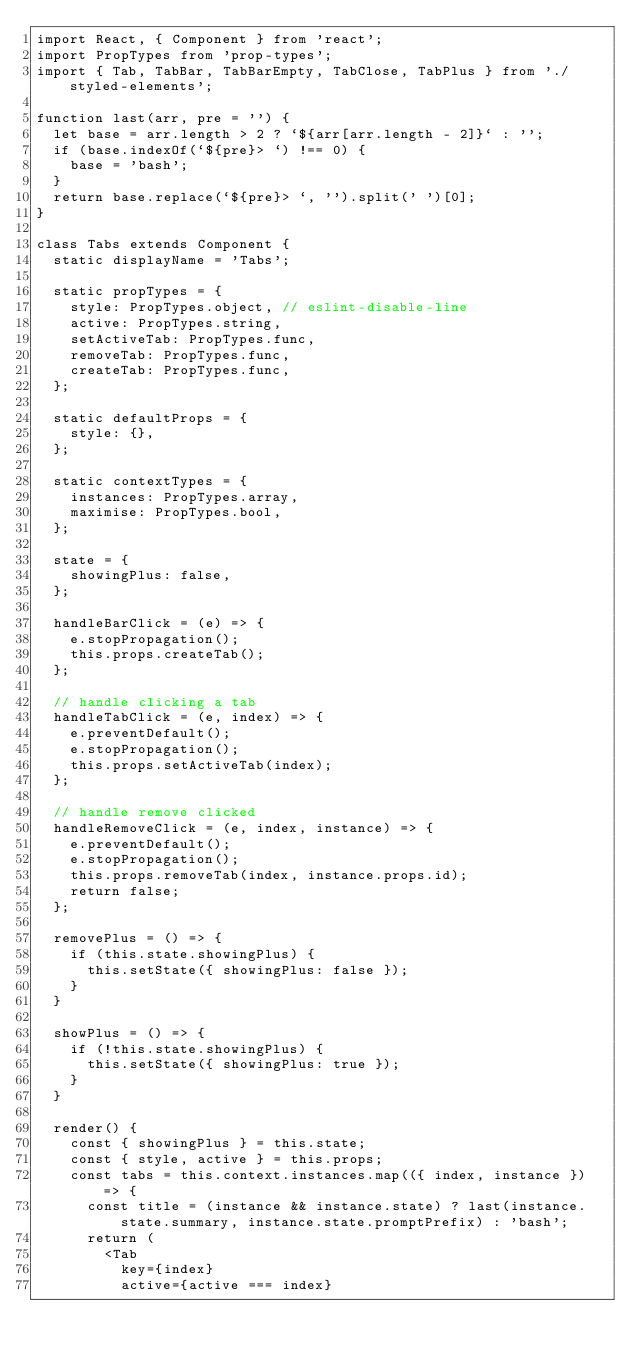Convert code to text. <code><loc_0><loc_0><loc_500><loc_500><_JavaScript_>import React, { Component } from 'react';
import PropTypes from 'prop-types';
import { Tab, TabBar, TabBarEmpty, TabClose, TabPlus } from './styled-elements';

function last(arr, pre = '') {
  let base = arr.length > 2 ? `${arr[arr.length - 2]}` : '';
  if (base.indexOf(`${pre}> `) !== 0) {
    base = 'bash';
  }
  return base.replace(`${pre}> `, '').split(' ')[0];
}

class Tabs extends Component {
  static displayName = 'Tabs';

  static propTypes = {
    style: PropTypes.object, // eslint-disable-line
    active: PropTypes.string,
    setActiveTab: PropTypes.func,
    removeTab: PropTypes.func,
    createTab: PropTypes.func,
  };

  static defaultProps = {
    style: {},
  };

  static contextTypes = {
    instances: PropTypes.array,
    maximise: PropTypes.bool,
  };

  state = {
    showingPlus: false,
  };

  handleBarClick = (e) => {
    e.stopPropagation();
    this.props.createTab();
  };

  // handle clicking a tab
  handleTabClick = (e, index) => {
    e.preventDefault();
    e.stopPropagation();
    this.props.setActiveTab(index);
  };

  // handle remove clicked
  handleRemoveClick = (e, index, instance) => {
    e.preventDefault();
    e.stopPropagation();
    this.props.removeTab(index, instance.props.id);
    return false;
  };

  removePlus = () => {
    if (this.state.showingPlus) {
      this.setState({ showingPlus: false });
    }
  }

  showPlus = () => {
    if (!this.state.showingPlus) {
      this.setState({ showingPlus: true });
    }
  }

  render() {
    const { showingPlus } = this.state;
    const { style, active } = this.props;
    const tabs = this.context.instances.map(({ index, instance }) => {
      const title = (instance && instance.state) ? last(instance.state.summary, instance.state.promptPrefix) : 'bash';
      return (
        <Tab
          key={index}
          active={active === index}</code> 